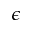<formula> <loc_0><loc_0><loc_500><loc_500>\epsilon</formula> 